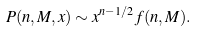Convert formula to latex. <formula><loc_0><loc_0><loc_500><loc_500>P ( n , M , x ) \sim x ^ { n - 1 / 2 } f ( n , M ) .</formula> 